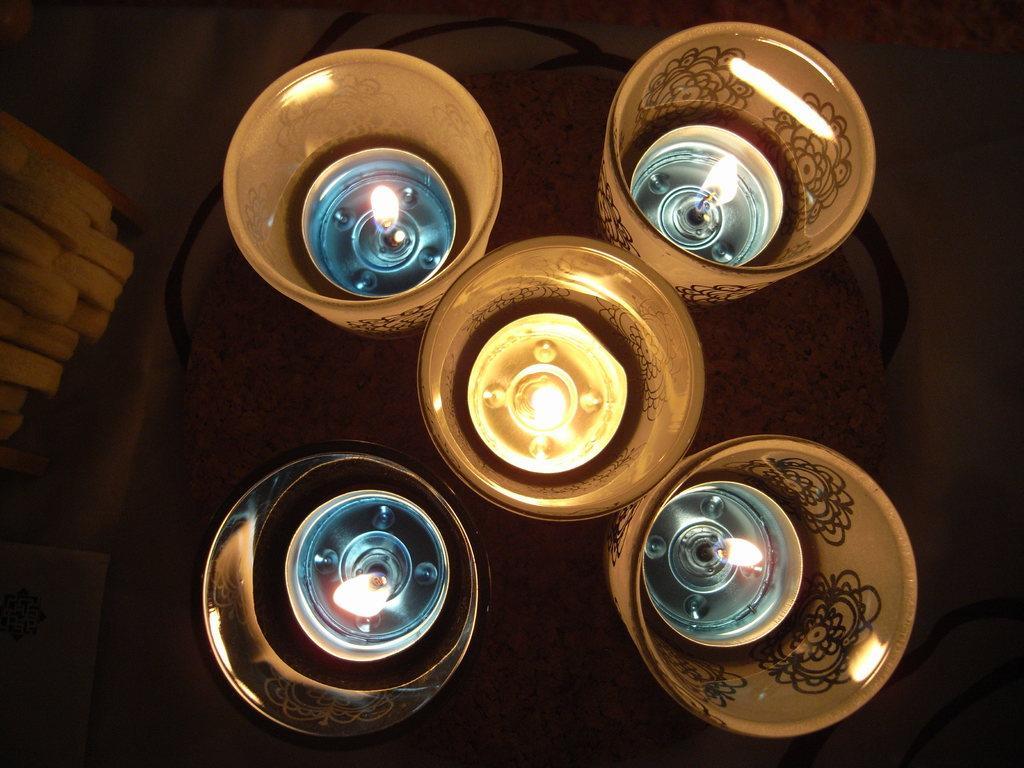Describe this image in one or two sentences. In this picture we can see candles in glasses on the table and we can see few objects. 